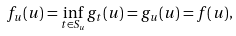<formula> <loc_0><loc_0><loc_500><loc_500>f _ { u } ( u ) = \inf _ { t \in S _ { u } } g _ { t } ( u ) = g _ { u } ( u ) = f ( u ) ,</formula> 